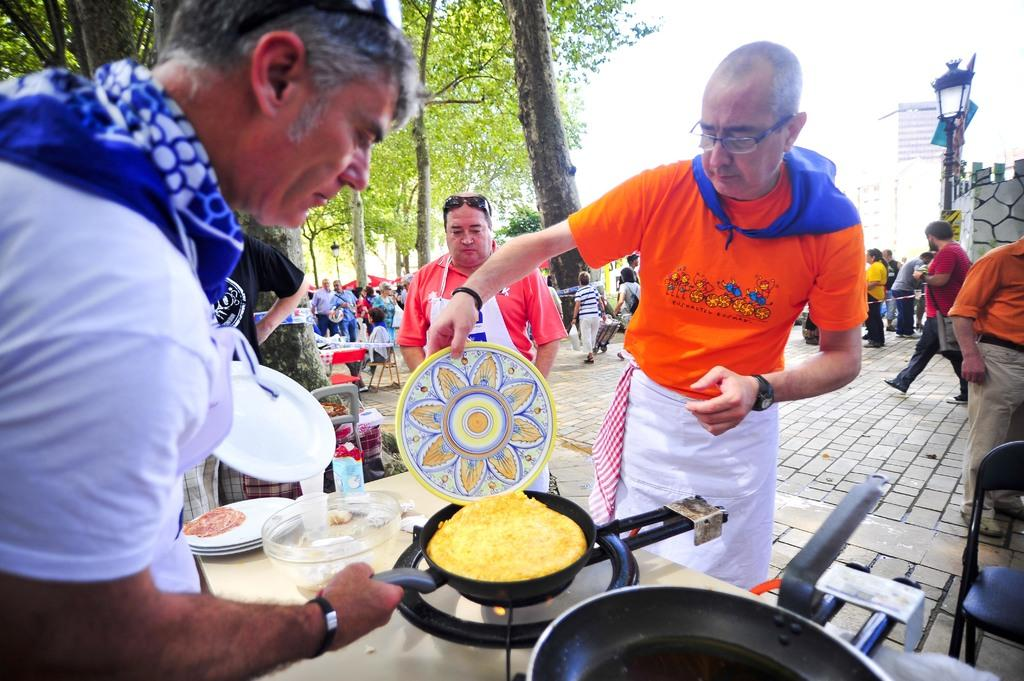What is the person in the image doing? The person is cooking food on a stove. Where is the person located in the image? The person is standing beside a table. Are there any other people present in the image? Yes, there are other people standing nearby. What can be seen in the background of the image? There are trees visible in the image. What type of art can be seen hanging on the trees in the image? There is no art visible on the trees in the image. Is there a scarecrow standing among the trees in the image? There is no scarecrow present in the image. 